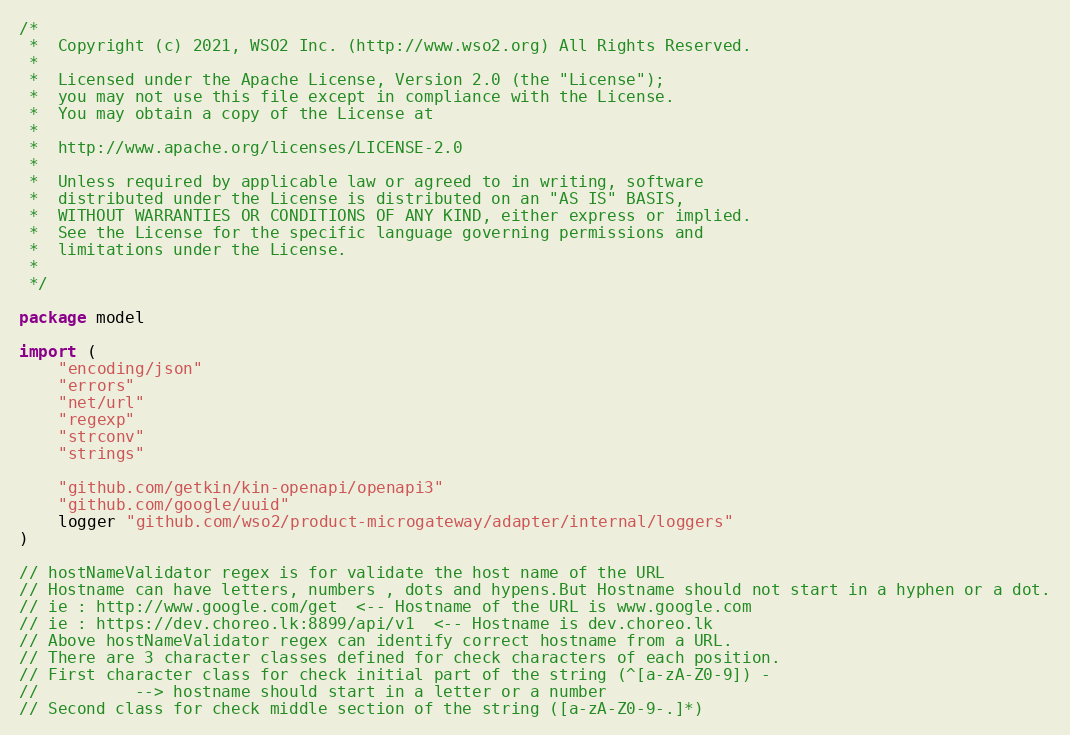Convert code to text. <code><loc_0><loc_0><loc_500><loc_500><_Go_>/*
 *  Copyright (c) 2021, WSO2 Inc. (http://www.wso2.org) All Rights Reserved.
 *
 *  Licensed under the Apache License, Version 2.0 (the "License");
 *  you may not use this file except in compliance with the License.
 *  You may obtain a copy of the License at
 *
 *  http://www.apache.org/licenses/LICENSE-2.0
 *
 *  Unless required by applicable law or agreed to in writing, software
 *  distributed under the License is distributed on an "AS IS" BASIS,
 *  WITHOUT WARRANTIES OR CONDITIONS OF ANY KIND, either express or implied.
 *  See the License for the specific language governing permissions and
 *  limitations under the License.
 *
 */

package model

import (
	"encoding/json"
	"errors"
	"net/url"
	"regexp"
	"strconv"
	"strings"

	"github.com/getkin/kin-openapi/openapi3"
	"github.com/google/uuid"
	logger "github.com/wso2/product-microgateway/adapter/internal/loggers"
)

// hostNameValidator regex is for validate the host name of the URL
// Hostname can have letters, numbers , dots and hypens.But Hostname should not start in a hyphen or a dot.
// ie : http://www.google.com/get  <-- Hostname of the URL is www.google.com
// ie : https://dev.choreo.lk:8899/api/v1  <-- Hostname is dev.choreo.lk
// Above hostNameValidator regex can identify correct hostname from a URL.
// There are 3 character classes defined for check characters of each position.
// First character class for check initial part of the string (^[a-zA-Z0-9]) -
//			--> hostname should start in a letter or a number
// Second class for check middle section of the string ([a-zA-Z0-9-.]*)</code> 